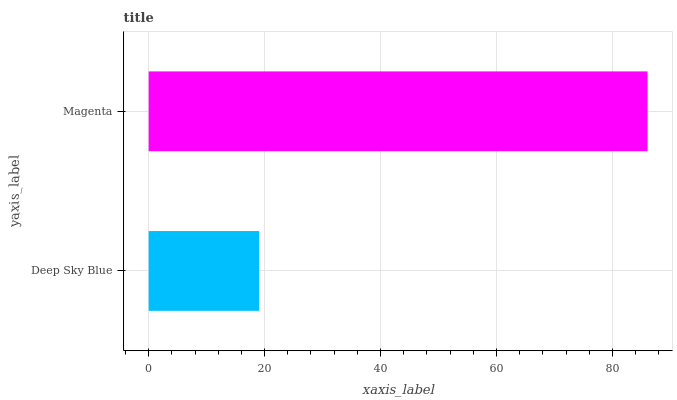Is Deep Sky Blue the minimum?
Answer yes or no. Yes. Is Magenta the maximum?
Answer yes or no. Yes. Is Magenta the minimum?
Answer yes or no. No. Is Magenta greater than Deep Sky Blue?
Answer yes or no. Yes. Is Deep Sky Blue less than Magenta?
Answer yes or no. Yes. Is Deep Sky Blue greater than Magenta?
Answer yes or no. No. Is Magenta less than Deep Sky Blue?
Answer yes or no. No. Is Magenta the high median?
Answer yes or no. Yes. Is Deep Sky Blue the low median?
Answer yes or no. Yes. Is Deep Sky Blue the high median?
Answer yes or no. No. Is Magenta the low median?
Answer yes or no. No. 